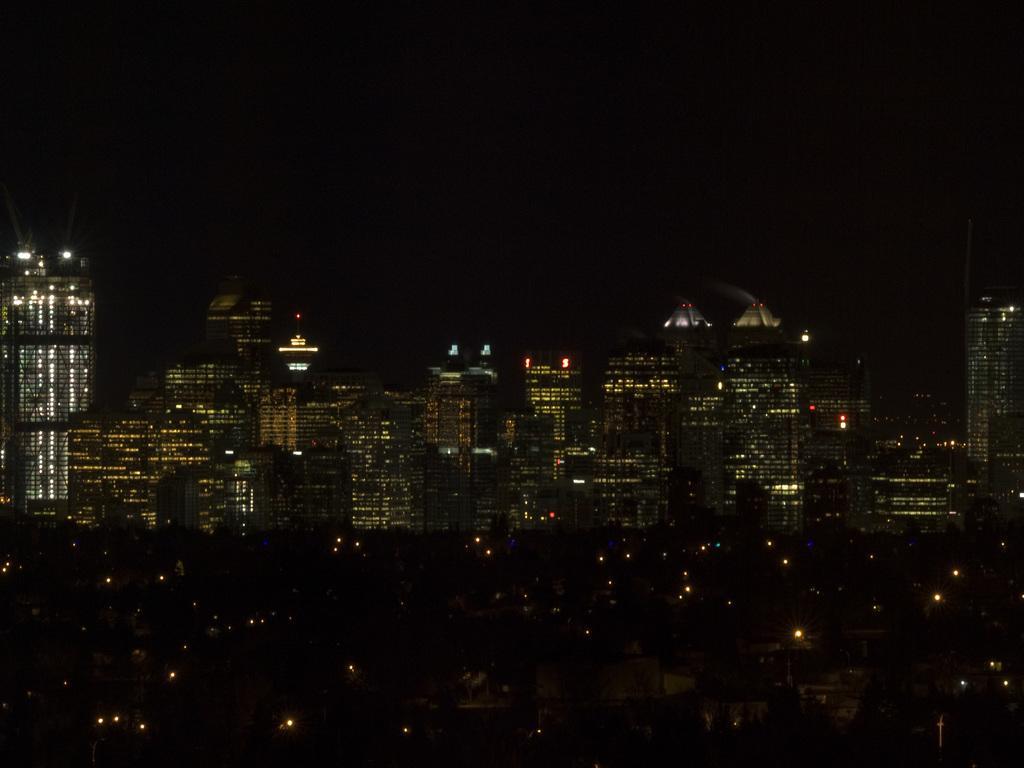How would you summarize this image in a sentence or two? In the background of the image there are buildings. At the top of the image there is sky. This image is taken during the night time. 